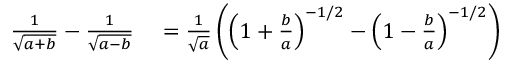<formula> <loc_0><loc_0><loc_500><loc_500>\begin{array} { r l } { { \frac { 1 } { \sqrt { a + b } } } - { \frac { 1 } { \sqrt { a - b } } } } & = { \frac { 1 } { \sqrt { a } } } \left ( \left ( 1 + { \frac { b } { a } } \right ) ^ { - 1 / 2 } - \left ( 1 - { \frac { b } { a } } \right ) ^ { - 1 / 2 } \right ) } \end{array}</formula> 